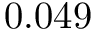<formula> <loc_0><loc_0><loc_500><loc_500>0 . 0 4 9</formula> 